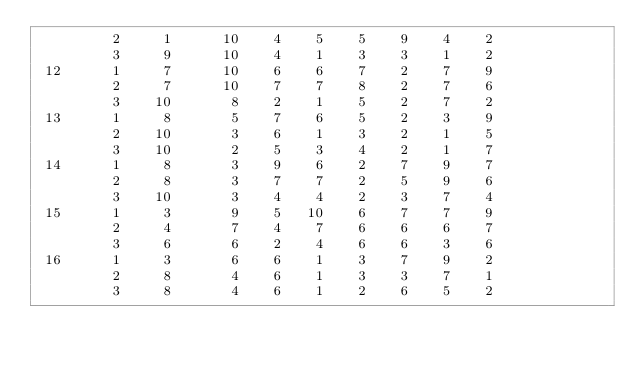Convert code to text. <code><loc_0><loc_0><loc_500><loc_500><_ObjectiveC_>         2     1      10    4    5    5    9    4    2
         3     9      10    4    1    3    3    1    2
 12      1     7      10    6    6    7    2    7    9
         2     7      10    7    7    8    2    7    6
         3    10       8    2    1    5    2    7    2
 13      1     8       5    7    6    5    2    3    9
         2    10       3    6    1    3    2    1    5
         3    10       2    5    3    4    2    1    7
 14      1     8       3    9    6    2    7    9    7
         2     8       3    7    7    2    5    9    6
         3    10       3    4    4    2    3    7    4
 15      1     3       9    5   10    6    7    7    9
         2     4       7    4    7    6    6    6    7
         3     6       6    2    4    6    6    3    6
 16      1     3       6    6    1    3    7    9    2
         2     8       4    6    1    3    3    7    1
         3     8       4    6    1    2    6    5    2</code> 